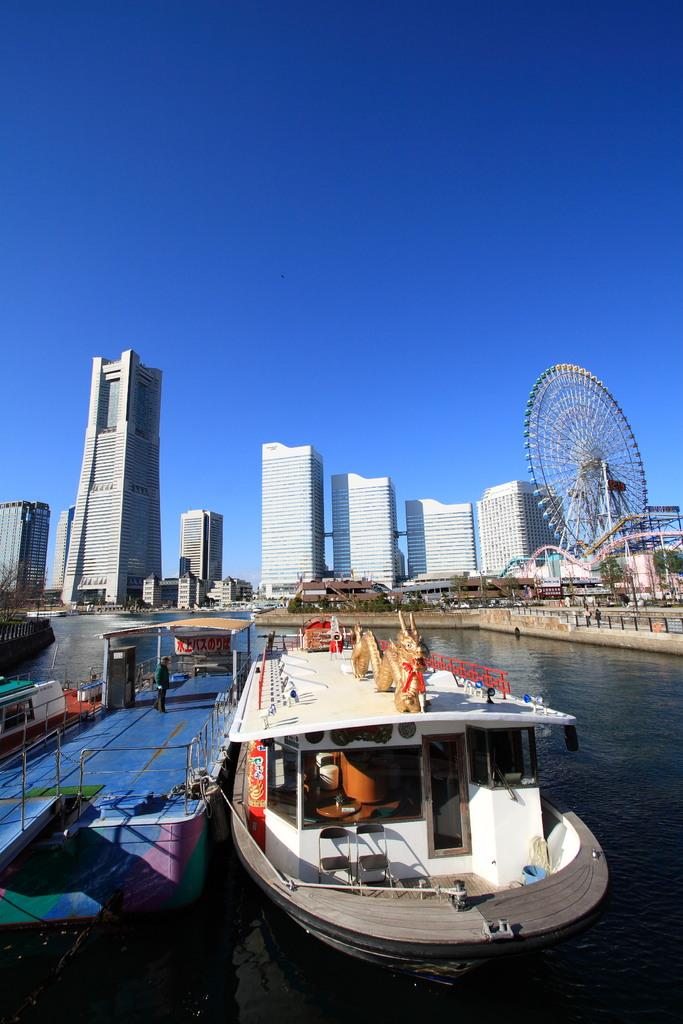What is the main subject of the image? The main subject of the image is a boat. Where is the boat located? The boat is on the water. Can you describe the background of the image? In the background, there is a person standing, a giant wheel, buildings in white color, trees in green color, and a blue sky. What type of business activity is taking place on the boat in the image? There is no indication of any business activity taking place on the boat in the image. How does the behavior of the trees in the background affect the overall mood of the image? The trees in the background do not have any behavior, as they are inanimate objects. The mood of the image is not affected by the trees' presence. 